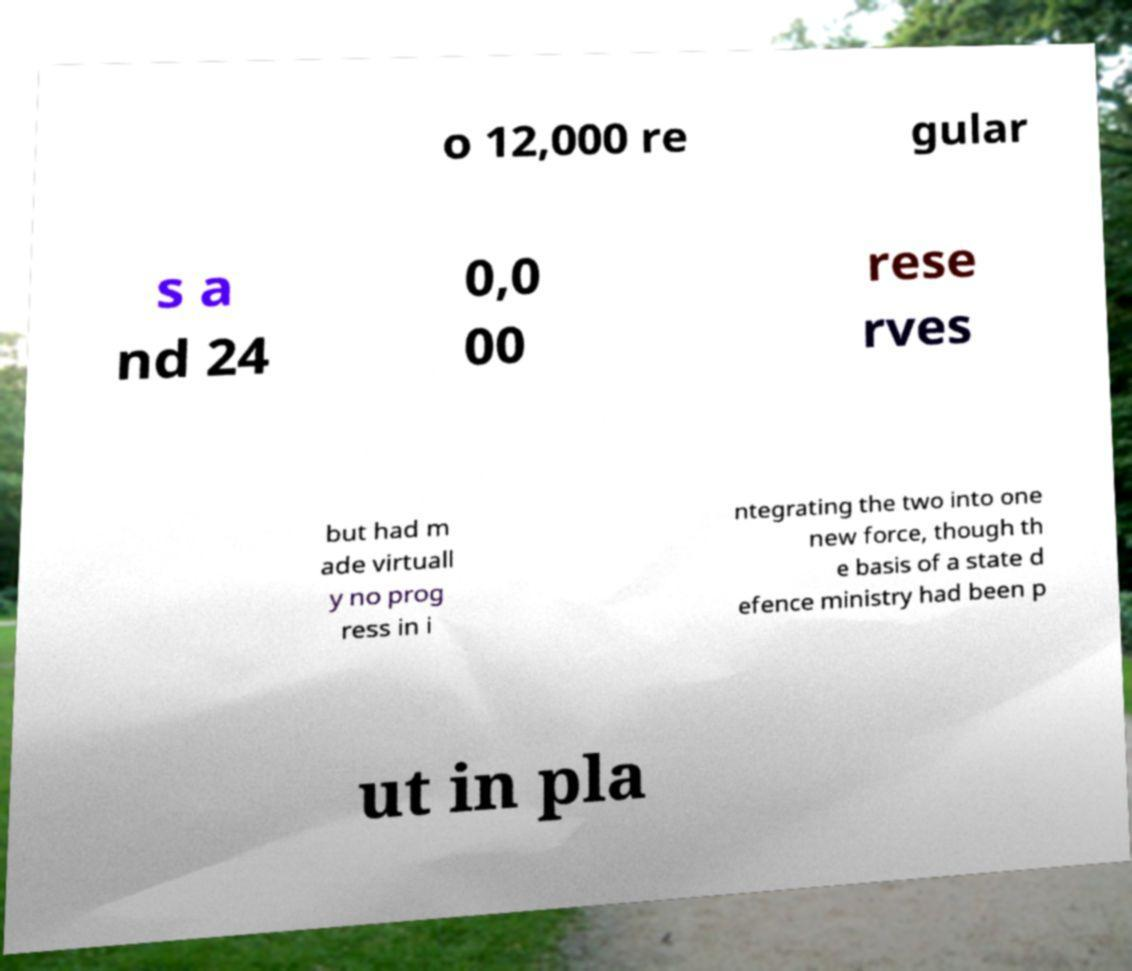Can you accurately transcribe the text from the provided image for me? o 12,000 re gular s a nd 24 0,0 00 rese rves but had m ade virtuall y no prog ress in i ntegrating the two into one new force, though th e basis of a state d efence ministry had been p ut in pla 